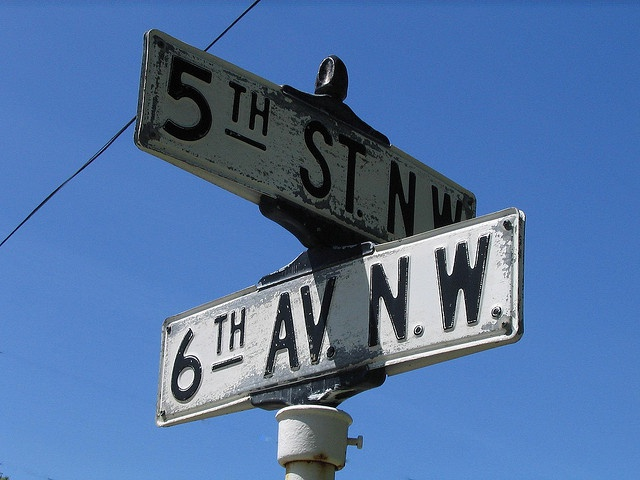Describe the objects in this image and their specific colors. I can see various objects in this image with different colors. 